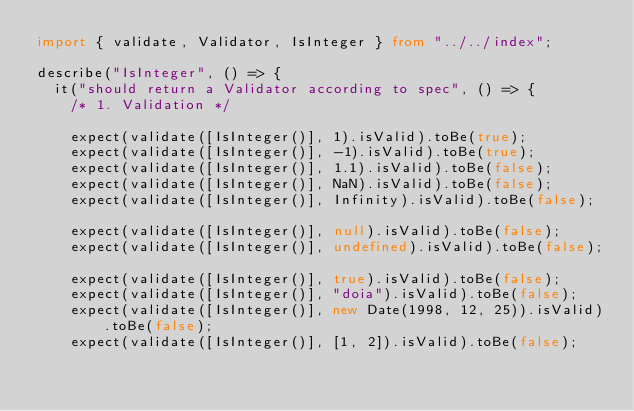Convert code to text. <code><loc_0><loc_0><loc_500><loc_500><_TypeScript_>import { validate, Validator, IsInteger } from "../../index";

describe("IsInteger", () => {
  it("should return a Validator according to spec", () => {
    /* 1. Validation */

    expect(validate([IsInteger()], 1).isValid).toBe(true);
    expect(validate([IsInteger()], -1).isValid).toBe(true);
    expect(validate([IsInteger()], 1.1).isValid).toBe(false);
    expect(validate([IsInteger()], NaN).isValid).toBe(false);
    expect(validate([IsInteger()], Infinity).isValid).toBe(false);

    expect(validate([IsInteger()], null).isValid).toBe(false);
    expect(validate([IsInteger()], undefined).isValid).toBe(false);

    expect(validate([IsInteger()], true).isValid).toBe(false);
    expect(validate([IsInteger()], "doia").isValid).toBe(false);
    expect(validate([IsInteger()], new Date(1998, 12, 25)).isValid).toBe(false);
    expect(validate([IsInteger()], [1, 2]).isValid).toBe(false);</code> 